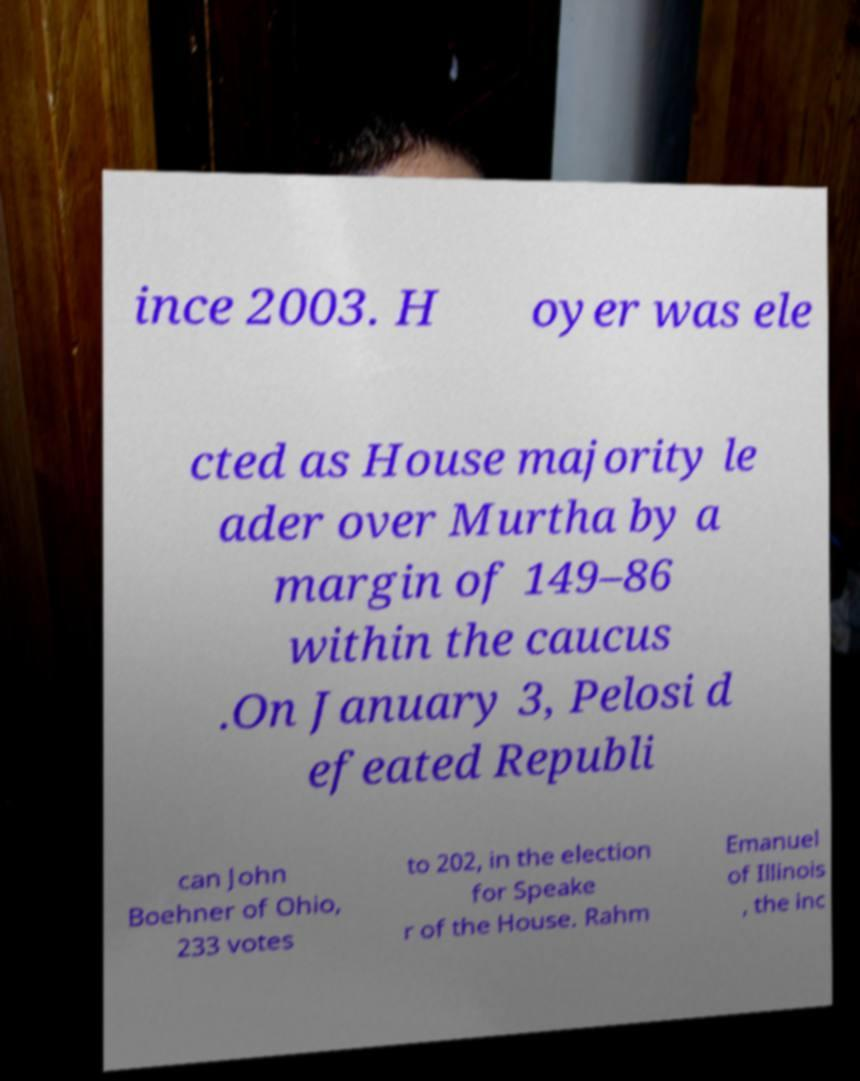For documentation purposes, I need the text within this image transcribed. Could you provide that? ince 2003. H oyer was ele cted as House majority le ader over Murtha by a margin of 149–86 within the caucus .On January 3, Pelosi d efeated Republi can John Boehner of Ohio, 233 votes to 202, in the election for Speake r of the House. Rahm Emanuel of Illinois , the inc 